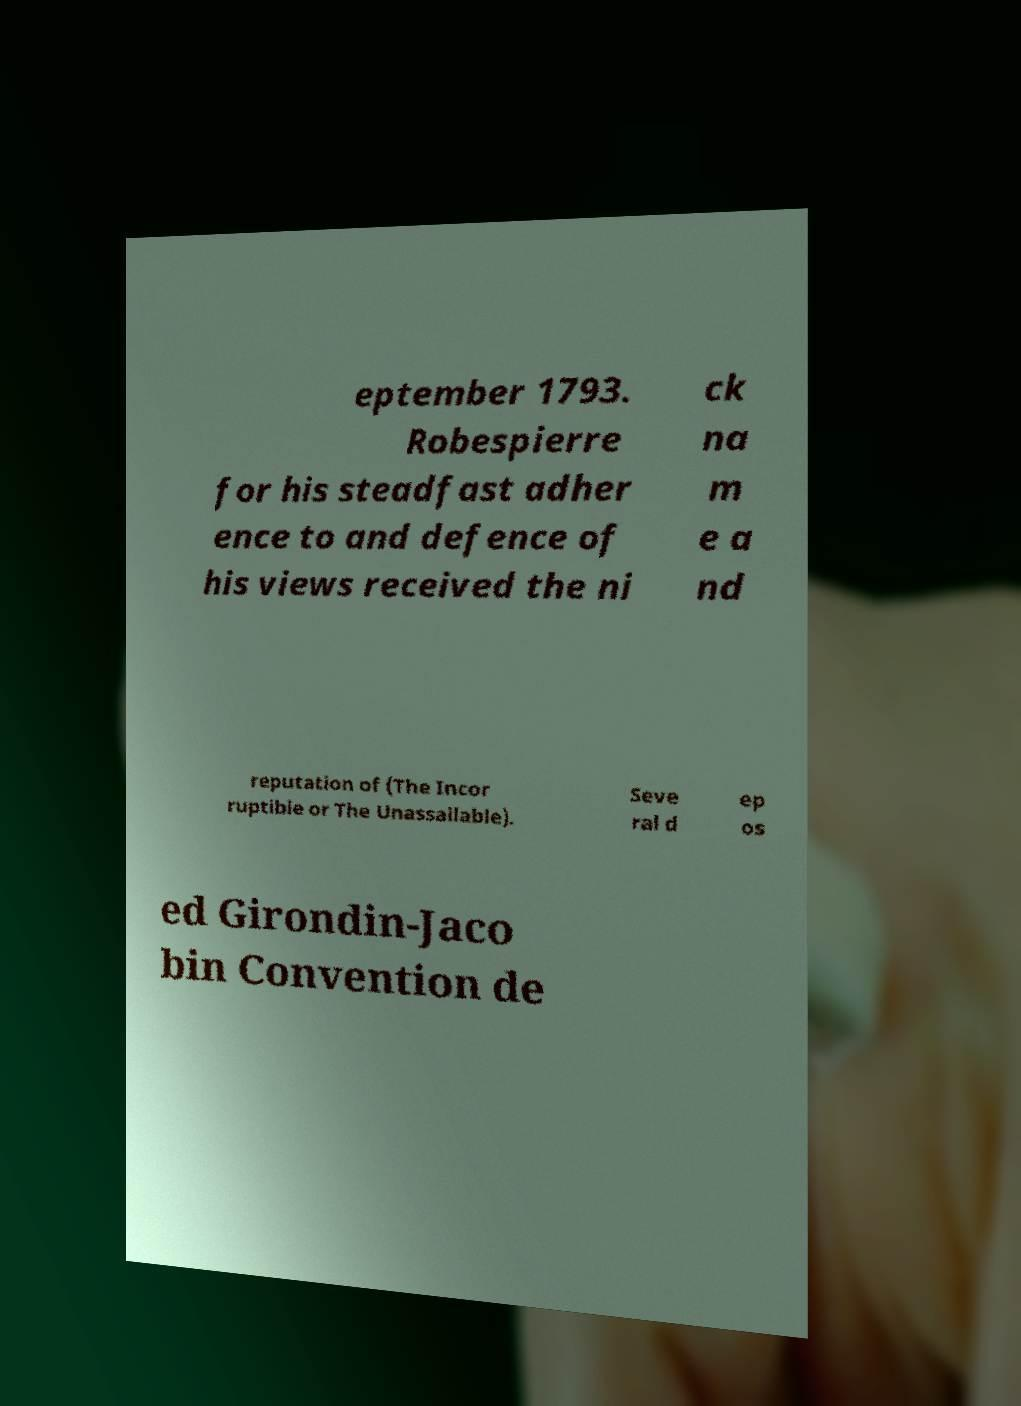For documentation purposes, I need the text within this image transcribed. Could you provide that? eptember 1793. Robespierre for his steadfast adher ence to and defence of his views received the ni ck na m e a nd reputation of (The Incor ruptible or The Unassailable). Seve ral d ep os ed Girondin-Jaco bin Convention de 